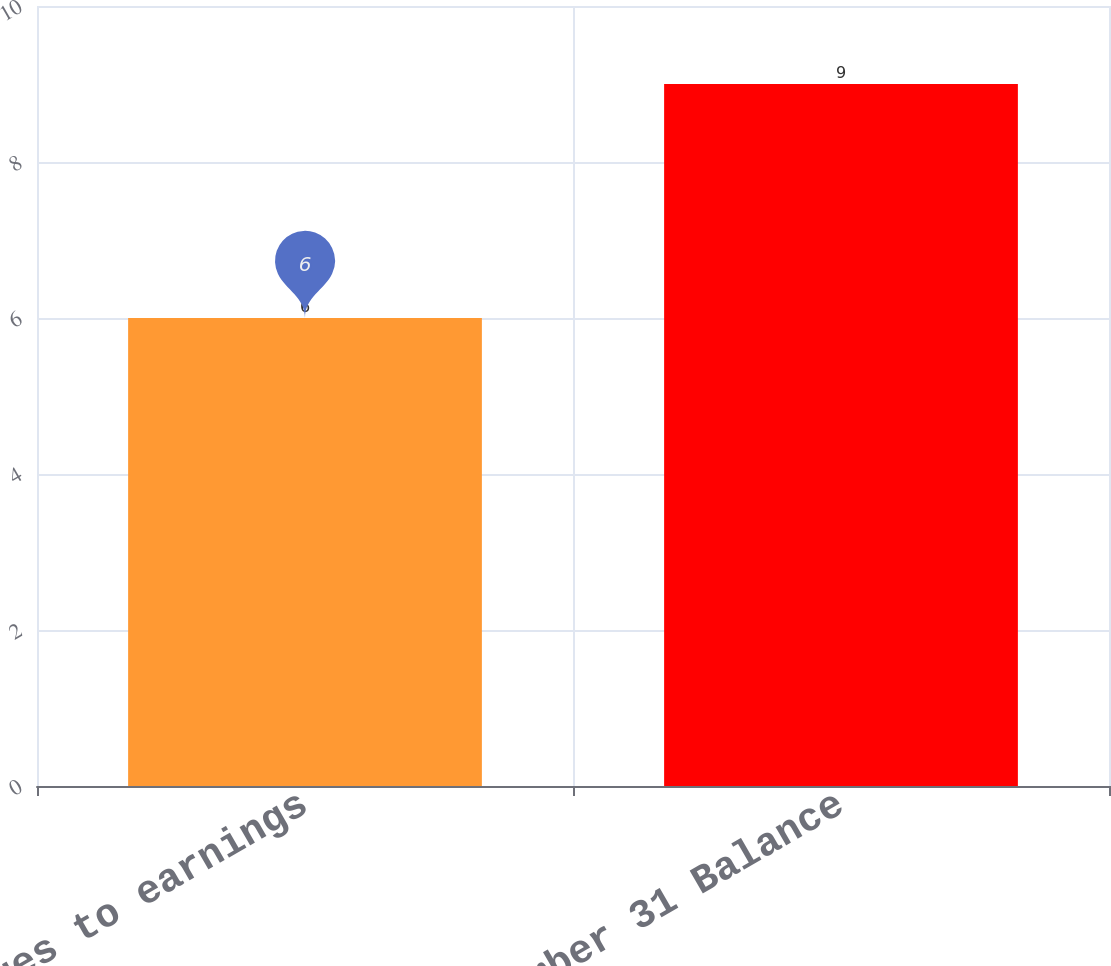<chart> <loc_0><loc_0><loc_500><loc_500><bar_chart><fcel>Charges to earnings<fcel>December 31 Balance<nl><fcel>6<fcel>9<nl></chart> 